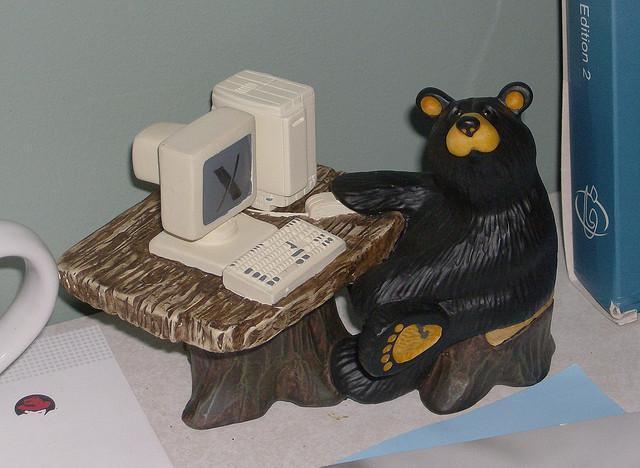Verify the accuracy of this image caption: "The tv is in front of the teddy bear.".
Answer yes or no. Yes. 